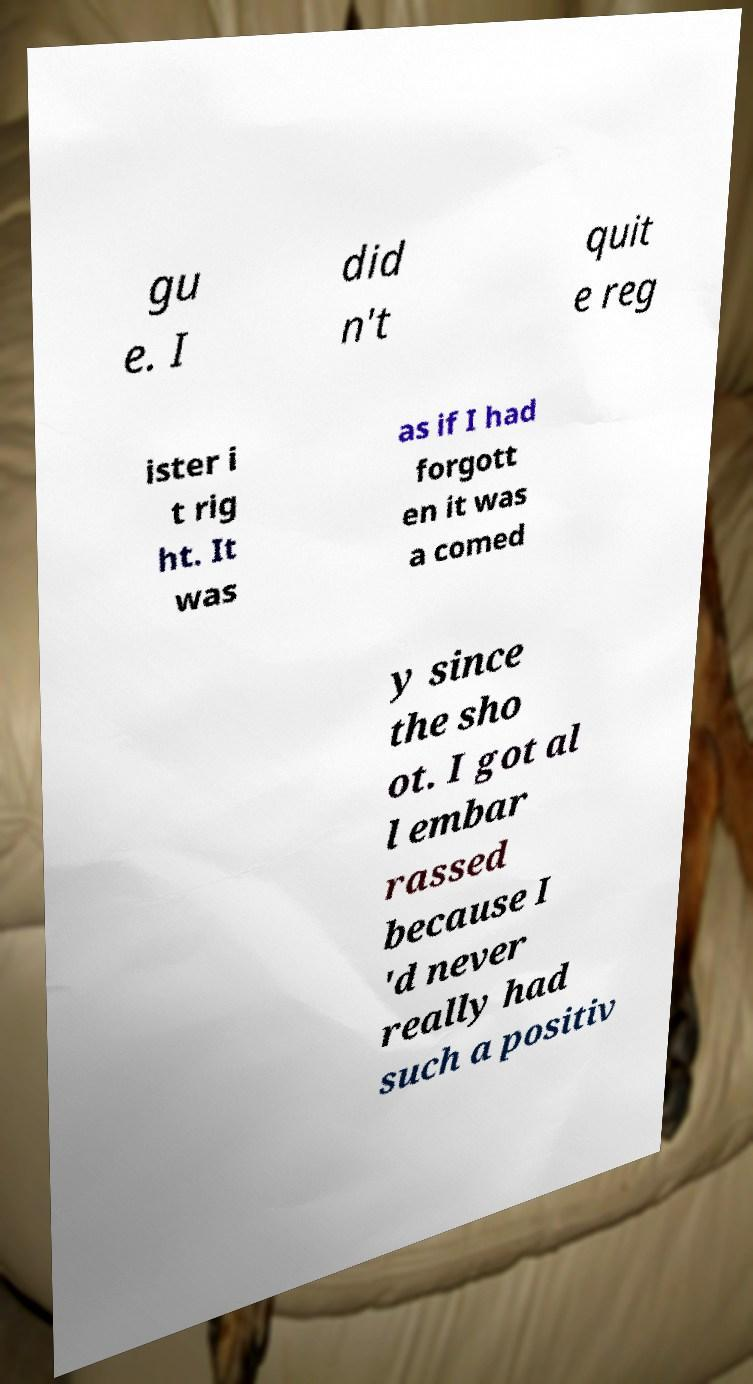Please identify and transcribe the text found in this image. gu e. I did n't quit e reg ister i t rig ht. It was as if I had forgott en it was a comed y since the sho ot. I got al l embar rassed because I 'd never really had such a positiv 